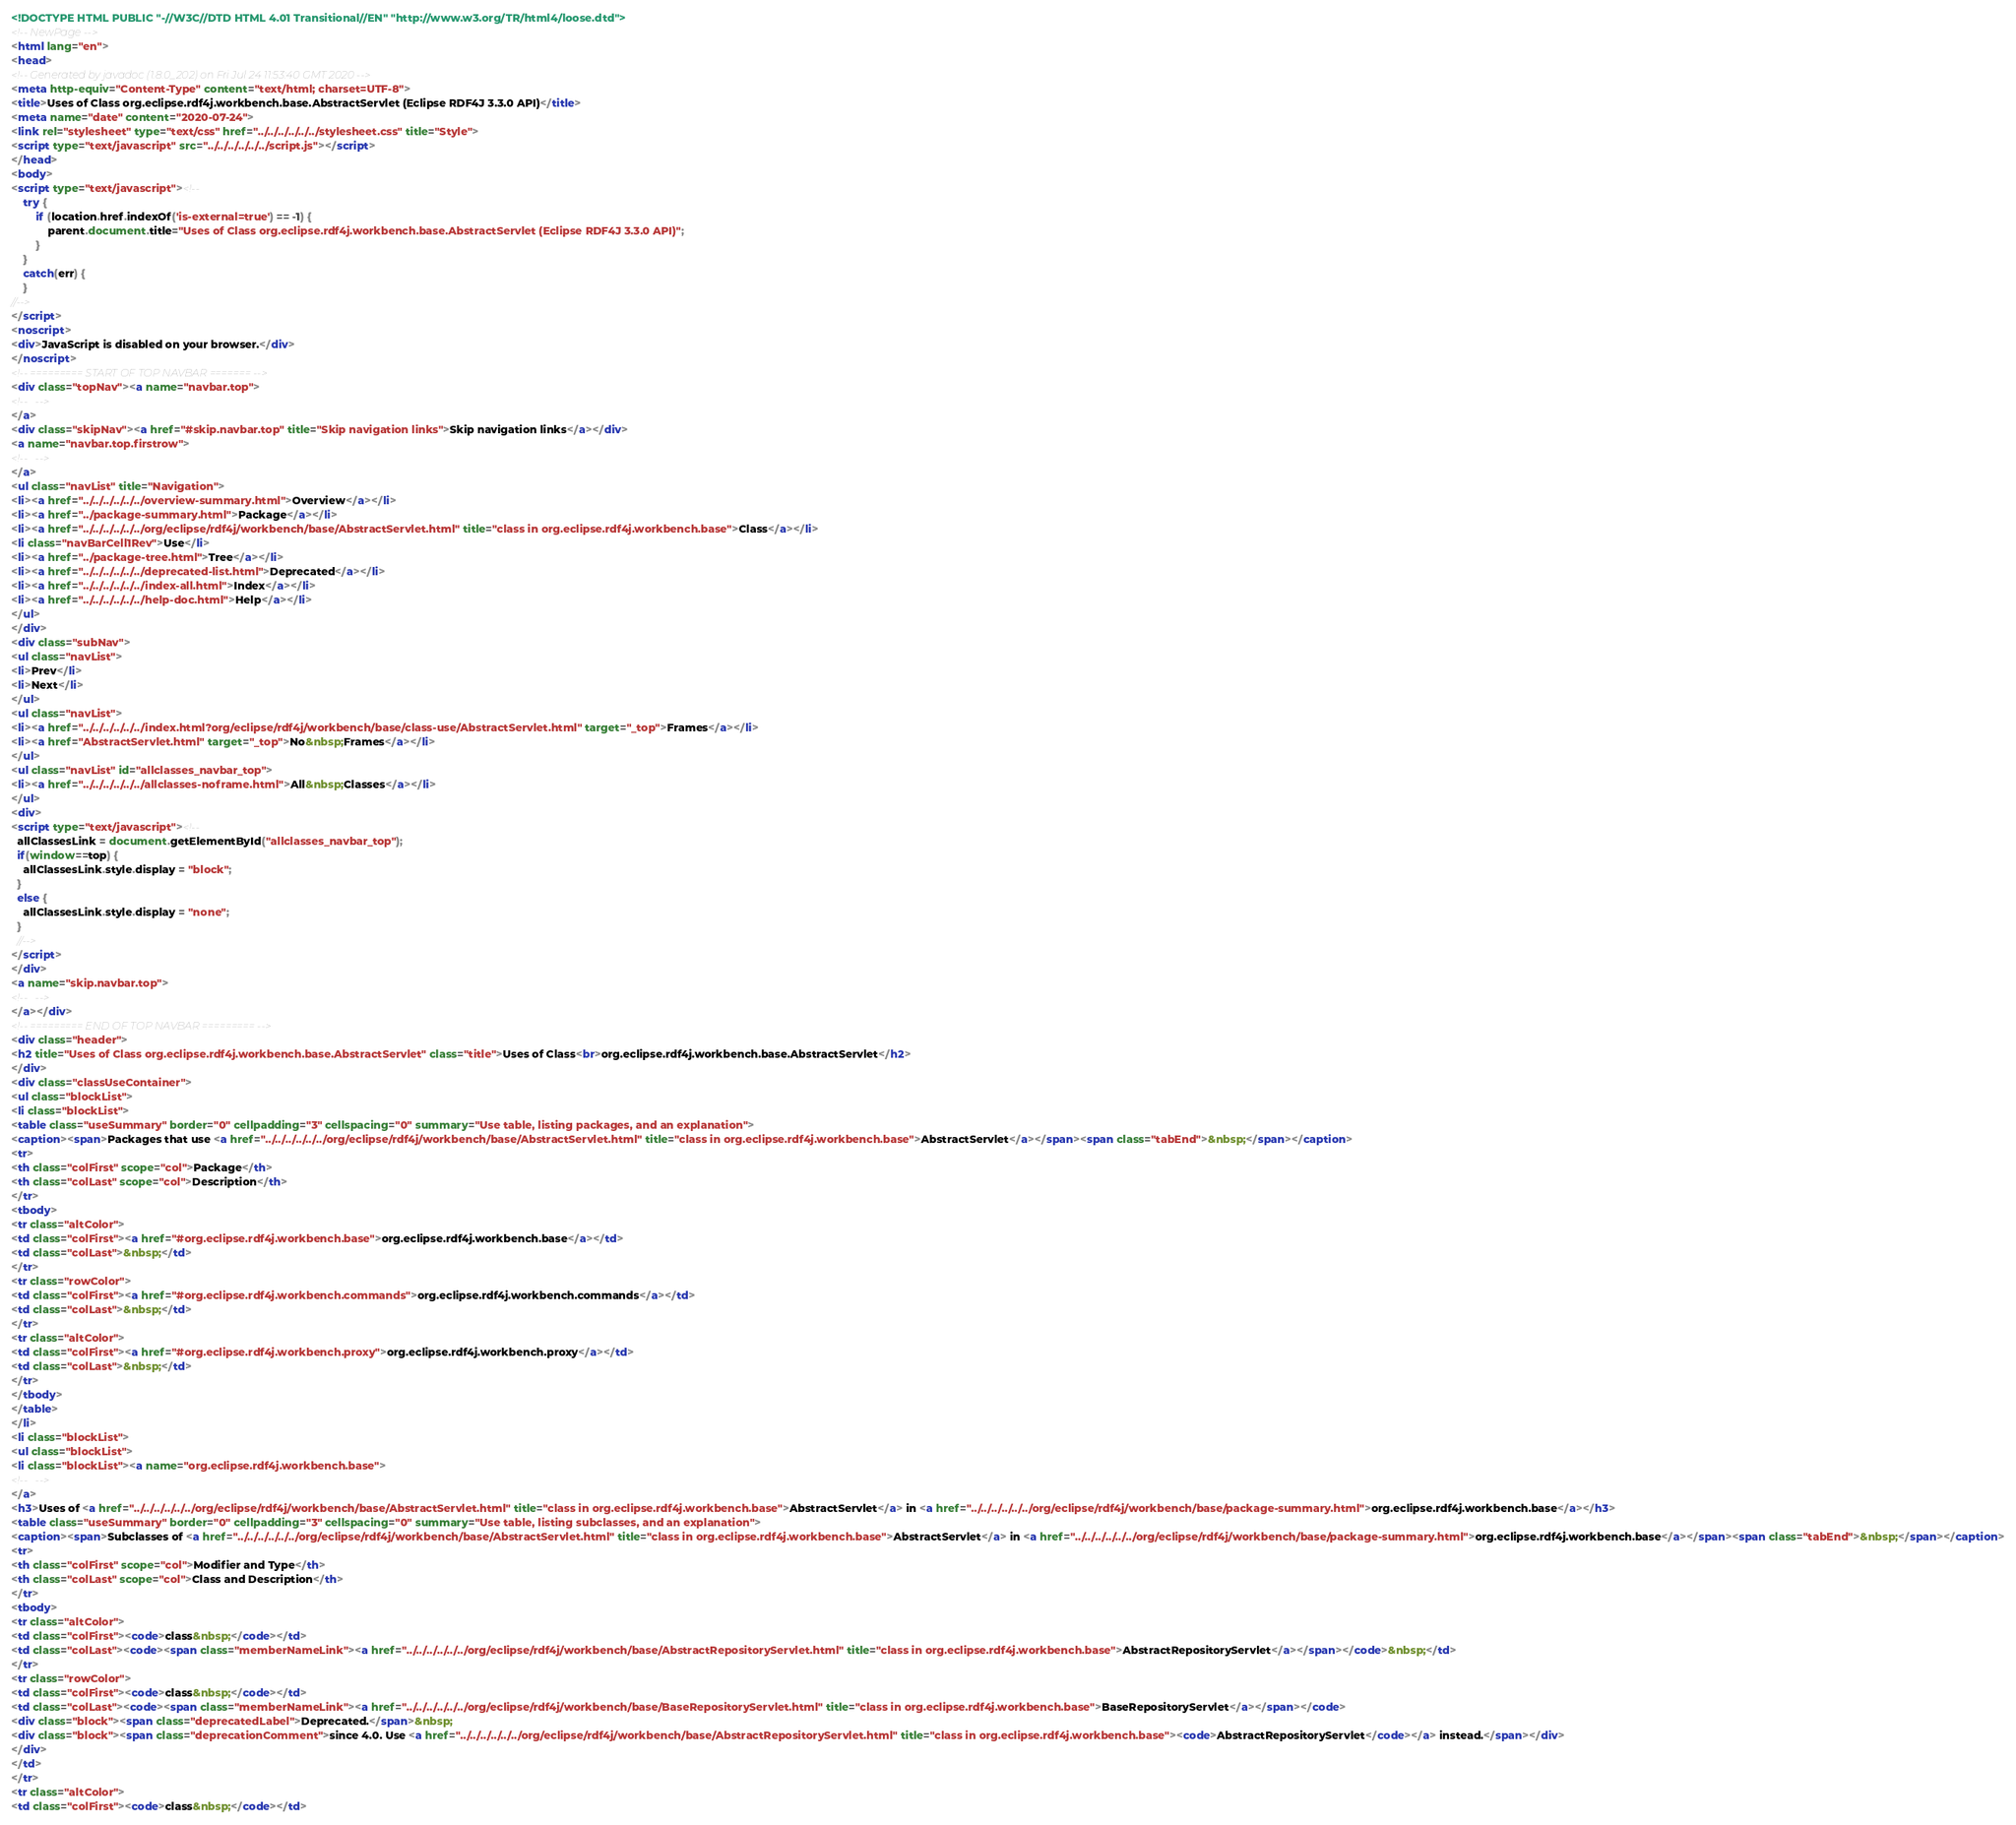<code> <loc_0><loc_0><loc_500><loc_500><_HTML_><!DOCTYPE HTML PUBLIC "-//W3C//DTD HTML 4.01 Transitional//EN" "http://www.w3.org/TR/html4/loose.dtd">
<!-- NewPage -->
<html lang="en">
<head>
<!-- Generated by javadoc (1.8.0_202) on Fri Jul 24 11:53:40 GMT 2020 -->
<meta http-equiv="Content-Type" content="text/html; charset=UTF-8">
<title>Uses of Class org.eclipse.rdf4j.workbench.base.AbstractServlet (Eclipse RDF4J 3.3.0 API)</title>
<meta name="date" content="2020-07-24">
<link rel="stylesheet" type="text/css" href="../../../../../../stylesheet.css" title="Style">
<script type="text/javascript" src="../../../../../../script.js"></script>
</head>
<body>
<script type="text/javascript"><!--
    try {
        if (location.href.indexOf('is-external=true') == -1) {
            parent.document.title="Uses of Class org.eclipse.rdf4j.workbench.base.AbstractServlet (Eclipse RDF4J 3.3.0 API)";
        }
    }
    catch(err) {
    }
//-->
</script>
<noscript>
<div>JavaScript is disabled on your browser.</div>
</noscript>
<!-- ========= START OF TOP NAVBAR ======= -->
<div class="topNav"><a name="navbar.top">
<!--   -->
</a>
<div class="skipNav"><a href="#skip.navbar.top" title="Skip navigation links">Skip navigation links</a></div>
<a name="navbar.top.firstrow">
<!--   -->
</a>
<ul class="navList" title="Navigation">
<li><a href="../../../../../../overview-summary.html">Overview</a></li>
<li><a href="../package-summary.html">Package</a></li>
<li><a href="../../../../../../org/eclipse/rdf4j/workbench/base/AbstractServlet.html" title="class in org.eclipse.rdf4j.workbench.base">Class</a></li>
<li class="navBarCell1Rev">Use</li>
<li><a href="../package-tree.html">Tree</a></li>
<li><a href="../../../../../../deprecated-list.html">Deprecated</a></li>
<li><a href="../../../../../../index-all.html">Index</a></li>
<li><a href="../../../../../../help-doc.html">Help</a></li>
</ul>
</div>
<div class="subNav">
<ul class="navList">
<li>Prev</li>
<li>Next</li>
</ul>
<ul class="navList">
<li><a href="../../../../../../index.html?org/eclipse/rdf4j/workbench/base/class-use/AbstractServlet.html" target="_top">Frames</a></li>
<li><a href="AbstractServlet.html" target="_top">No&nbsp;Frames</a></li>
</ul>
<ul class="navList" id="allclasses_navbar_top">
<li><a href="../../../../../../allclasses-noframe.html">All&nbsp;Classes</a></li>
</ul>
<div>
<script type="text/javascript"><!--
  allClassesLink = document.getElementById("allclasses_navbar_top");
  if(window==top) {
    allClassesLink.style.display = "block";
  }
  else {
    allClassesLink.style.display = "none";
  }
  //-->
</script>
</div>
<a name="skip.navbar.top">
<!--   -->
</a></div>
<!-- ========= END OF TOP NAVBAR ========= -->
<div class="header">
<h2 title="Uses of Class org.eclipse.rdf4j.workbench.base.AbstractServlet" class="title">Uses of Class<br>org.eclipse.rdf4j.workbench.base.AbstractServlet</h2>
</div>
<div class="classUseContainer">
<ul class="blockList">
<li class="blockList">
<table class="useSummary" border="0" cellpadding="3" cellspacing="0" summary="Use table, listing packages, and an explanation">
<caption><span>Packages that use <a href="../../../../../../org/eclipse/rdf4j/workbench/base/AbstractServlet.html" title="class in org.eclipse.rdf4j.workbench.base">AbstractServlet</a></span><span class="tabEnd">&nbsp;</span></caption>
<tr>
<th class="colFirst" scope="col">Package</th>
<th class="colLast" scope="col">Description</th>
</tr>
<tbody>
<tr class="altColor">
<td class="colFirst"><a href="#org.eclipse.rdf4j.workbench.base">org.eclipse.rdf4j.workbench.base</a></td>
<td class="colLast">&nbsp;</td>
</tr>
<tr class="rowColor">
<td class="colFirst"><a href="#org.eclipse.rdf4j.workbench.commands">org.eclipse.rdf4j.workbench.commands</a></td>
<td class="colLast">&nbsp;</td>
</tr>
<tr class="altColor">
<td class="colFirst"><a href="#org.eclipse.rdf4j.workbench.proxy">org.eclipse.rdf4j.workbench.proxy</a></td>
<td class="colLast">&nbsp;</td>
</tr>
</tbody>
</table>
</li>
<li class="blockList">
<ul class="blockList">
<li class="blockList"><a name="org.eclipse.rdf4j.workbench.base">
<!--   -->
</a>
<h3>Uses of <a href="../../../../../../org/eclipse/rdf4j/workbench/base/AbstractServlet.html" title="class in org.eclipse.rdf4j.workbench.base">AbstractServlet</a> in <a href="../../../../../../org/eclipse/rdf4j/workbench/base/package-summary.html">org.eclipse.rdf4j.workbench.base</a></h3>
<table class="useSummary" border="0" cellpadding="3" cellspacing="0" summary="Use table, listing subclasses, and an explanation">
<caption><span>Subclasses of <a href="../../../../../../org/eclipse/rdf4j/workbench/base/AbstractServlet.html" title="class in org.eclipse.rdf4j.workbench.base">AbstractServlet</a> in <a href="../../../../../../org/eclipse/rdf4j/workbench/base/package-summary.html">org.eclipse.rdf4j.workbench.base</a></span><span class="tabEnd">&nbsp;</span></caption>
<tr>
<th class="colFirst" scope="col">Modifier and Type</th>
<th class="colLast" scope="col">Class and Description</th>
</tr>
<tbody>
<tr class="altColor">
<td class="colFirst"><code>class&nbsp;</code></td>
<td class="colLast"><code><span class="memberNameLink"><a href="../../../../../../org/eclipse/rdf4j/workbench/base/AbstractRepositoryServlet.html" title="class in org.eclipse.rdf4j.workbench.base">AbstractRepositoryServlet</a></span></code>&nbsp;</td>
</tr>
<tr class="rowColor">
<td class="colFirst"><code>class&nbsp;</code></td>
<td class="colLast"><code><span class="memberNameLink"><a href="../../../../../../org/eclipse/rdf4j/workbench/base/BaseRepositoryServlet.html" title="class in org.eclipse.rdf4j.workbench.base">BaseRepositoryServlet</a></span></code>
<div class="block"><span class="deprecatedLabel">Deprecated.</span>&nbsp;
<div class="block"><span class="deprecationComment">since 4.0. Use <a href="../../../../../../org/eclipse/rdf4j/workbench/base/AbstractRepositoryServlet.html" title="class in org.eclipse.rdf4j.workbench.base"><code>AbstractRepositoryServlet</code></a> instead.</span></div>
</div>
</td>
</tr>
<tr class="altColor">
<td class="colFirst"><code>class&nbsp;</code></td></code> 